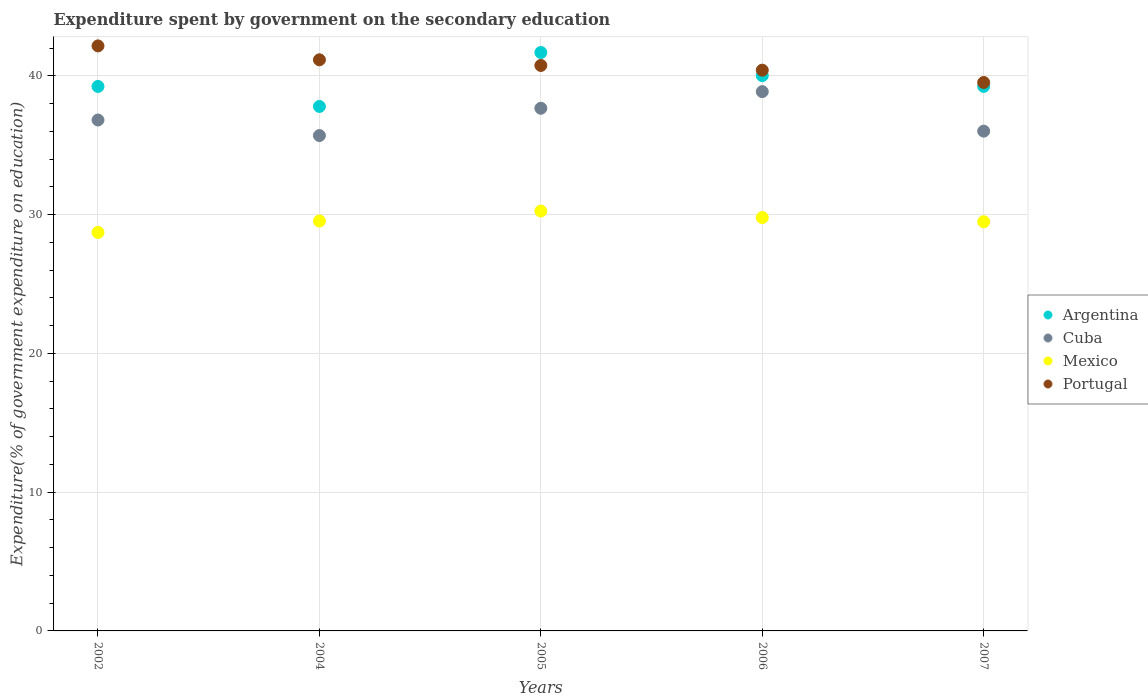What is the expenditure spent by government on the secondary education in Cuba in 2006?
Your answer should be compact. 38.87. Across all years, what is the maximum expenditure spent by government on the secondary education in Argentina?
Offer a terse response. 41.69. Across all years, what is the minimum expenditure spent by government on the secondary education in Mexico?
Ensure brevity in your answer.  28.72. In which year was the expenditure spent by government on the secondary education in Portugal minimum?
Offer a terse response. 2007. What is the total expenditure spent by government on the secondary education in Portugal in the graph?
Make the answer very short. 204.02. What is the difference between the expenditure spent by government on the secondary education in Cuba in 2002 and that in 2007?
Your answer should be compact. 0.8. What is the difference between the expenditure spent by government on the secondary education in Argentina in 2002 and the expenditure spent by government on the secondary education in Portugal in 2005?
Your response must be concise. -1.51. What is the average expenditure spent by government on the secondary education in Portugal per year?
Your answer should be very brief. 40.8. In the year 2005, what is the difference between the expenditure spent by government on the secondary education in Portugal and expenditure spent by government on the secondary education in Mexico?
Your answer should be compact. 10.49. What is the ratio of the expenditure spent by government on the secondary education in Mexico in 2004 to that in 2007?
Provide a succinct answer. 1. Is the expenditure spent by government on the secondary education in Mexico in 2002 less than that in 2004?
Your answer should be very brief. Yes. What is the difference between the highest and the second highest expenditure spent by government on the secondary education in Portugal?
Keep it short and to the point. 1. What is the difference between the highest and the lowest expenditure spent by government on the secondary education in Mexico?
Ensure brevity in your answer.  1.54. In how many years, is the expenditure spent by government on the secondary education in Mexico greater than the average expenditure spent by government on the secondary education in Mexico taken over all years?
Offer a terse response. 2. Is it the case that in every year, the sum of the expenditure spent by government on the secondary education in Mexico and expenditure spent by government on the secondary education in Portugal  is greater than the sum of expenditure spent by government on the secondary education in Cuba and expenditure spent by government on the secondary education in Argentina?
Keep it short and to the point. Yes. How many years are there in the graph?
Keep it short and to the point. 5. What is the difference between two consecutive major ticks on the Y-axis?
Keep it short and to the point. 10. Are the values on the major ticks of Y-axis written in scientific E-notation?
Keep it short and to the point. No. How many legend labels are there?
Provide a succinct answer. 4. What is the title of the graph?
Your response must be concise. Expenditure spent by government on the secondary education. Does "St. Martin (French part)" appear as one of the legend labels in the graph?
Keep it short and to the point. No. What is the label or title of the X-axis?
Your answer should be very brief. Years. What is the label or title of the Y-axis?
Offer a terse response. Expenditure(% of government expenditure on education). What is the Expenditure(% of government expenditure on education) in Argentina in 2002?
Ensure brevity in your answer.  39.24. What is the Expenditure(% of government expenditure on education) in Cuba in 2002?
Your answer should be very brief. 36.82. What is the Expenditure(% of government expenditure on education) of Mexico in 2002?
Provide a succinct answer. 28.72. What is the Expenditure(% of government expenditure on education) in Portugal in 2002?
Provide a succinct answer. 42.16. What is the Expenditure(% of government expenditure on education) in Argentina in 2004?
Offer a very short reply. 37.8. What is the Expenditure(% of government expenditure on education) in Cuba in 2004?
Your answer should be very brief. 35.7. What is the Expenditure(% of government expenditure on education) in Mexico in 2004?
Make the answer very short. 29.54. What is the Expenditure(% of government expenditure on education) in Portugal in 2004?
Ensure brevity in your answer.  41.16. What is the Expenditure(% of government expenditure on education) of Argentina in 2005?
Make the answer very short. 41.69. What is the Expenditure(% of government expenditure on education) in Cuba in 2005?
Your answer should be very brief. 37.67. What is the Expenditure(% of government expenditure on education) in Mexico in 2005?
Make the answer very short. 30.26. What is the Expenditure(% of government expenditure on education) of Portugal in 2005?
Make the answer very short. 40.75. What is the Expenditure(% of government expenditure on education) in Argentina in 2006?
Keep it short and to the point. 40.02. What is the Expenditure(% of government expenditure on education) of Cuba in 2006?
Offer a very short reply. 38.87. What is the Expenditure(% of government expenditure on education) of Mexico in 2006?
Your answer should be compact. 29.79. What is the Expenditure(% of government expenditure on education) of Portugal in 2006?
Your answer should be very brief. 40.41. What is the Expenditure(% of government expenditure on education) in Argentina in 2007?
Keep it short and to the point. 39.25. What is the Expenditure(% of government expenditure on education) in Cuba in 2007?
Provide a short and direct response. 36.02. What is the Expenditure(% of government expenditure on education) in Mexico in 2007?
Make the answer very short. 29.49. What is the Expenditure(% of government expenditure on education) in Portugal in 2007?
Your answer should be very brief. 39.53. Across all years, what is the maximum Expenditure(% of government expenditure on education) in Argentina?
Your answer should be very brief. 41.69. Across all years, what is the maximum Expenditure(% of government expenditure on education) of Cuba?
Make the answer very short. 38.87. Across all years, what is the maximum Expenditure(% of government expenditure on education) in Mexico?
Give a very brief answer. 30.26. Across all years, what is the maximum Expenditure(% of government expenditure on education) of Portugal?
Make the answer very short. 42.16. Across all years, what is the minimum Expenditure(% of government expenditure on education) of Argentina?
Your answer should be very brief. 37.8. Across all years, what is the minimum Expenditure(% of government expenditure on education) of Cuba?
Offer a very short reply. 35.7. Across all years, what is the minimum Expenditure(% of government expenditure on education) of Mexico?
Offer a very short reply. 28.72. Across all years, what is the minimum Expenditure(% of government expenditure on education) in Portugal?
Make the answer very short. 39.53. What is the total Expenditure(% of government expenditure on education) in Argentina in the graph?
Provide a succinct answer. 197.99. What is the total Expenditure(% of government expenditure on education) of Cuba in the graph?
Your answer should be very brief. 185.08. What is the total Expenditure(% of government expenditure on education) of Mexico in the graph?
Provide a succinct answer. 147.81. What is the total Expenditure(% of government expenditure on education) in Portugal in the graph?
Keep it short and to the point. 204.02. What is the difference between the Expenditure(% of government expenditure on education) of Argentina in 2002 and that in 2004?
Provide a succinct answer. 1.44. What is the difference between the Expenditure(% of government expenditure on education) in Cuba in 2002 and that in 2004?
Your answer should be very brief. 1.12. What is the difference between the Expenditure(% of government expenditure on education) in Mexico in 2002 and that in 2004?
Your response must be concise. -0.82. What is the difference between the Expenditure(% of government expenditure on education) in Argentina in 2002 and that in 2005?
Provide a succinct answer. -2.45. What is the difference between the Expenditure(% of government expenditure on education) of Cuba in 2002 and that in 2005?
Your response must be concise. -0.85. What is the difference between the Expenditure(% of government expenditure on education) of Mexico in 2002 and that in 2005?
Provide a short and direct response. -1.54. What is the difference between the Expenditure(% of government expenditure on education) of Portugal in 2002 and that in 2005?
Ensure brevity in your answer.  1.41. What is the difference between the Expenditure(% of government expenditure on education) of Argentina in 2002 and that in 2006?
Your answer should be compact. -0.78. What is the difference between the Expenditure(% of government expenditure on education) of Cuba in 2002 and that in 2006?
Provide a succinct answer. -2.05. What is the difference between the Expenditure(% of government expenditure on education) in Mexico in 2002 and that in 2006?
Your response must be concise. -1.07. What is the difference between the Expenditure(% of government expenditure on education) of Portugal in 2002 and that in 2006?
Provide a short and direct response. 1.75. What is the difference between the Expenditure(% of government expenditure on education) of Argentina in 2002 and that in 2007?
Your response must be concise. -0. What is the difference between the Expenditure(% of government expenditure on education) of Cuba in 2002 and that in 2007?
Make the answer very short. 0.8. What is the difference between the Expenditure(% of government expenditure on education) in Mexico in 2002 and that in 2007?
Offer a terse response. -0.77. What is the difference between the Expenditure(% of government expenditure on education) of Portugal in 2002 and that in 2007?
Make the answer very short. 2.64. What is the difference between the Expenditure(% of government expenditure on education) of Argentina in 2004 and that in 2005?
Make the answer very short. -3.89. What is the difference between the Expenditure(% of government expenditure on education) of Cuba in 2004 and that in 2005?
Give a very brief answer. -1.97. What is the difference between the Expenditure(% of government expenditure on education) of Mexico in 2004 and that in 2005?
Provide a succinct answer. -0.72. What is the difference between the Expenditure(% of government expenditure on education) of Portugal in 2004 and that in 2005?
Make the answer very short. 0.41. What is the difference between the Expenditure(% of government expenditure on education) in Argentina in 2004 and that in 2006?
Your answer should be compact. -2.22. What is the difference between the Expenditure(% of government expenditure on education) in Cuba in 2004 and that in 2006?
Offer a terse response. -3.17. What is the difference between the Expenditure(% of government expenditure on education) of Mexico in 2004 and that in 2006?
Your response must be concise. -0.25. What is the difference between the Expenditure(% of government expenditure on education) of Portugal in 2004 and that in 2006?
Your response must be concise. 0.75. What is the difference between the Expenditure(% of government expenditure on education) of Argentina in 2004 and that in 2007?
Give a very brief answer. -1.45. What is the difference between the Expenditure(% of government expenditure on education) of Cuba in 2004 and that in 2007?
Offer a very short reply. -0.32. What is the difference between the Expenditure(% of government expenditure on education) in Mexico in 2004 and that in 2007?
Your answer should be very brief. 0.05. What is the difference between the Expenditure(% of government expenditure on education) in Portugal in 2004 and that in 2007?
Keep it short and to the point. 1.63. What is the difference between the Expenditure(% of government expenditure on education) in Argentina in 2005 and that in 2006?
Keep it short and to the point. 1.67. What is the difference between the Expenditure(% of government expenditure on education) in Mexico in 2005 and that in 2006?
Provide a succinct answer. 0.47. What is the difference between the Expenditure(% of government expenditure on education) of Portugal in 2005 and that in 2006?
Your response must be concise. 0.34. What is the difference between the Expenditure(% of government expenditure on education) in Argentina in 2005 and that in 2007?
Give a very brief answer. 2.44. What is the difference between the Expenditure(% of government expenditure on education) in Cuba in 2005 and that in 2007?
Provide a short and direct response. 1.65. What is the difference between the Expenditure(% of government expenditure on education) of Mexico in 2005 and that in 2007?
Ensure brevity in your answer.  0.77. What is the difference between the Expenditure(% of government expenditure on education) of Portugal in 2005 and that in 2007?
Offer a terse response. 1.23. What is the difference between the Expenditure(% of government expenditure on education) in Argentina in 2006 and that in 2007?
Provide a succinct answer. 0.78. What is the difference between the Expenditure(% of government expenditure on education) in Cuba in 2006 and that in 2007?
Keep it short and to the point. 2.85. What is the difference between the Expenditure(% of government expenditure on education) of Mexico in 2006 and that in 2007?
Offer a very short reply. 0.3. What is the difference between the Expenditure(% of government expenditure on education) of Portugal in 2006 and that in 2007?
Make the answer very short. 0.89. What is the difference between the Expenditure(% of government expenditure on education) in Argentina in 2002 and the Expenditure(% of government expenditure on education) in Cuba in 2004?
Keep it short and to the point. 3.54. What is the difference between the Expenditure(% of government expenditure on education) of Argentina in 2002 and the Expenditure(% of government expenditure on education) of Mexico in 2004?
Your response must be concise. 9.7. What is the difference between the Expenditure(% of government expenditure on education) of Argentina in 2002 and the Expenditure(% of government expenditure on education) of Portugal in 2004?
Give a very brief answer. -1.92. What is the difference between the Expenditure(% of government expenditure on education) of Cuba in 2002 and the Expenditure(% of government expenditure on education) of Mexico in 2004?
Your response must be concise. 7.28. What is the difference between the Expenditure(% of government expenditure on education) in Cuba in 2002 and the Expenditure(% of government expenditure on education) in Portugal in 2004?
Your response must be concise. -4.34. What is the difference between the Expenditure(% of government expenditure on education) in Mexico in 2002 and the Expenditure(% of government expenditure on education) in Portugal in 2004?
Provide a short and direct response. -12.44. What is the difference between the Expenditure(% of government expenditure on education) in Argentina in 2002 and the Expenditure(% of government expenditure on education) in Cuba in 2005?
Give a very brief answer. 1.57. What is the difference between the Expenditure(% of government expenditure on education) in Argentina in 2002 and the Expenditure(% of government expenditure on education) in Mexico in 2005?
Keep it short and to the point. 8.98. What is the difference between the Expenditure(% of government expenditure on education) in Argentina in 2002 and the Expenditure(% of government expenditure on education) in Portugal in 2005?
Offer a very short reply. -1.51. What is the difference between the Expenditure(% of government expenditure on education) of Cuba in 2002 and the Expenditure(% of government expenditure on education) of Mexico in 2005?
Offer a terse response. 6.56. What is the difference between the Expenditure(% of government expenditure on education) in Cuba in 2002 and the Expenditure(% of government expenditure on education) in Portugal in 2005?
Provide a short and direct response. -3.93. What is the difference between the Expenditure(% of government expenditure on education) of Mexico in 2002 and the Expenditure(% of government expenditure on education) of Portugal in 2005?
Offer a very short reply. -12.03. What is the difference between the Expenditure(% of government expenditure on education) of Argentina in 2002 and the Expenditure(% of government expenditure on education) of Cuba in 2006?
Keep it short and to the point. 0.37. What is the difference between the Expenditure(% of government expenditure on education) of Argentina in 2002 and the Expenditure(% of government expenditure on education) of Mexico in 2006?
Your response must be concise. 9.45. What is the difference between the Expenditure(% of government expenditure on education) of Argentina in 2002 and the Expenditure(% of government expenditure on education) of Portugal in 2006?
Your response must be concise. -1.17. What is the difference between the Expenditure(% of government expenditure on education) in Cuba in 2002 and the Expenditure(% of government expenditure on education) in Mexico in 2006?
Provide a succinct answer. 7.03. What is the difference between the Expenditure(% of government expenditure on education) of Cuba in 2002 and the Expenditure(% of government expenditure on education) of Portugal in 2006?
Make the answer very short. -3.59. What is the difference between the Expenditure(% of government expenditure on education) of Mexico in 2002 and the Expenditure(% of government expenditure on education) of Portugal in 2006?
Your response must be concise. -11.69. What is the difference between the Expenditure(% of government expenditure on education) of Argentina in 2002 and the Expenditure(% of government expenditure on education) of Cuba in 2007?
Your response must be concise. 3.22. What is the difference between the Expenditure(% of government expenditure on education) in Argentina in 2002 and the Expenditure(% of government expenditure on education) in Mexico in 2007?
Offer a very short reply. 9.75. What is the difference between the Expenditure(% of government expenditure on education) in Argentina in 2002 and the Expenditure(% of government expenditure on education) in Portugal in 2007?
Keep it short and to the point. -0.29. What is the difference between the Expenditure(% of government expenditure on education) of Cuba in 2002 and the Expenditure(% of government expenditure on education) of Mexico in 2007?
Provide a succinct answer. 7.33. What is the difference between the Expenditure(% of government expenditure on education) of Cuba in 2002 and the Expenditure(% of government expenditure on education) of Portugal in 2007?
Ensure brevity in your answer.  -2.71. What is the difference between the Expenditure(% of government expenditure on education) of Mexico in 2002 and the Expenditure(% of government expenditure on education) of Portugal in 2007?
Offer a very short reply. -10.81. What is the difference between the Expenditure(% of government expenditure on education) in Argentina in 2004 and the Expenditure(% of government expenditure on education) in Cuba in 2005?
Ensure brevity in your answer.  0.13. What is the difference between the Expenditure(% of government expenditure on education) in Argentina in 2004 and the Expenditure(% of government expenditure on education) in Mexico in 2005?
Your answer should be compact. 7.54. What is the difference between the Expenditure(% of government expenditure on education) in Argentina in 2004 and the Expenditure(% of government expenditure on education) in Portugal in 2005?
Keep it short and to the point. -2.95. What is the difference between the Expenditure(% of government expenditure on education) in Cuba in 2004 and the Expenditure(% of government expenditure on education) in Mexico in 2005?
Provide a short and direct response. 5.44. What is the difference between the Expenditure(% of government expenditure on education) of Cuba in 2004 and the Expenditure(% of government expenditure on education) of Portugal in 2005?
Your answer should be very brief. -5.05. What is the difference between the Expenditure(% of government expenditure on education) of Mexico in 2004 and the Expenditure(% of government expenditure on education) of Portugal in 2005?
Offer a very short reply. -11.21. What is the difference between the Expenditure(% of government expenditure on education) in Argentina in 2004 and the Expenditure(% of government expenditure on education) in Cuba in 2006?
Your response must be concise. -1.07. What is the difference between the Expenditure(% of government expenditure on education) of Argentina in 2004 and the Expenditure(% of government expenditure on education) of Mexico in 2006?
Keep it short and to the point. 8.01. What is the difference between the Expenditure(% of government expenditure on education) in Argentina in 2004 and the Expenditure(% of government expenditure on education) in Portugal in 2006?
Provide a succinct answer. -2.62. What is the difference between the Expenditure(% of government expenditure on education) in Cuba in 2004 and the Expenditure(% of government expenditure on education) in Mexico in 2006?
Offer a terse response. 5.91. What is the difference between the Expenditure(% of government expenditure on education) of Cuba in 2004 and the Expenditure(% of government expenditure on education) of Portugal in 2006?
Give a very brief answer. -4.71. What is the difference between the Expenditure(% of government expenditure on education) of Mexico in 2004 and the Expenditure(% of government expenditure on education) of Portugal in 2006?
Provide a short and direct response. -10.87. What is the difference between the Expenditure(% of government expenditure on education) of Argentina in 2004 and the Expenditure(% of government expenditure on education) of Cuba in 2007?
Provide a succinct answer. 1.78. What is the difference between the Expenditure(% of government expenditure on education) in Argentina in 2004 and the Expenditure(% of government expenditure on education) in Mexico in 2007?
Make the answer very short. 8.31. What is the difference between the Expenditure(% of government expenditure on education) of Argentina in 2004 and the Expenditure(% of government expenditure on education) of Portugal in 2007?
Offer a terse response. -1.73. What is the difference between the Expenditure(% of government expenditure on education) in Cuba in 2004 and the Expenditure(% of government expenditure on education) in Mexico in 2007?
Your response must be concise. 6.21. What is the difference between the Expenditure(% of government expenditure on education) of Cuba in 2004 and the Expenditure(% of government expenditure on education) of Portugal in 2007?
Give a very brief answer. -3.83. What is the difference between the Expenditure(% of government expenditure on education) in Mexico in 2004 and the Expenditure(% of government expenditure on education) in Portugal in 2007?
Provide a succinct answer. -9.98. What is the difference between the Expenditure(% of government expenditure on education) of Argentina in 2005 and the Expenditure(% of government expenditure on education) of Cuba in 2006?
Ensure brevity in your answer.  2.82. What is the difference between the Expenditure(% of government expenditure on education) in Argentina in 2005 and the Expenditure(% of government expenditure on education) in Mexico in 2006?
Your response must be concise. 11.9. What is the difference between the Expenditure(% of government expenditure on education) of Argentina in 2005 and the Expenditure(% of government expenditure on education) of Portugal in 2006?
Give a very brief answer. 1.27. What is the difference between the Expenditure(% of government expenditure on education) of Cuba in 2005 and the Expenditure(% of government expenditure on education) of Mexico in 2006?
Make the answer very short. 7.88. What is the difference between the Expenditure(% of government expenditure on education) in Cuba in 2005 and the Expenditure(% of government expenditure on education) in Portugal in 2006?
Give a very brief answer. -2.75. What is the difference between the Expenditure(% of government expenditure on education) in Mexico in 2005 and the Expenditure(% of government expenditure on education) in Portugal in 2006?
Make the answer very short. -10.15. What is the difference between the Expenditure(% of government expenditure on education) in Argentina in 2005 and the Expenditure(% of government expenditure on education) in Cuba in 2007?
Your response must be concise. 5.67. What is the difference between the Expenditure(% of government expenditure on education) in Argentina in 2005 and the Expenditure(% of government expenditure on education) in Mexico in 2007?
Provide a short and direct response. 12.2. What is the difference between the Expenditure(% of government expenditure on education) of Argentina in 2005 and the Expenditure(% of government expenditure on education) of Portugal in 2007?
Make the answer very short. 2.16. What is the difference between the Expenditure(% of government expenditure on education) of Cuba in 2005 and the Expenditure(% of government expenditure on education) of Mexico in 2007?
Ensure brevity in your answer.  8.18. What is the difference between the Expenditure(% of government expenditure on education) in Cuba in 2005 and the Expenditure(% of government expenditure on education) in Portugal in 2007?
Offer a terse response. -1.86. What is the difference between the Expenditure(% of government expenditure on education) in Mexico in 2005 and the Expenditure(% of government expenditure on education) in Portugal in 2007?
Offer a terse response. -9.27. What is the difference between the Expenditure(% of government expenditure on education) of Argentina in 2006 and the Expenditure(% of government expenditure on education) of Cuba in 2007?
Provide a succinct answer. 4. What is the difference between the Expenditure(% of government expenditure on education) of Argentina in 2006 and the Expenditure(% of government expenditure on education) of Mexico in 2007?
Give a very brief answer. 10.53. What is the difference between the Expenditure(% of government expenditure on education) of Argentina in 2006 and the Expenditure(% of government expenditure on education) of Portugal in 2007?
Keep it short and to the point. 0.49. What is the difference between the Expenditure(% of government expenditure on education) in Cuba in 2006 and the Expenditure(% of government expenditure on education) in Mexico in 2007?
Provide a short and direct response. 9.38. What is the difference between the Expenditure(% of government expenditure on education) in Cuba in 2006 and the Expenditure(% of government expenditure on education) in Portugal in 2007?
Offer a terse response. -0.66. What is the difference between the Expenditure(% of government expenditure on education) of Mexico in 2006 and the Expenditure(% of government expenditure on education) of Portugal in 2007?
Your answer should be very brief. -9.74. What is the average Expenditure(% of government expenditure on education) in Argentina per year?
Provide a succinct answer. 39.6. What is the average Expenditure(% of government expenditure on education) of Cuba per year?
Provide a succinct answer. 37.02. What is the average Expenditure(% of government expenditure on education) in Mexico per year?
Your answer should be very brief. 29.56. What is the average Expenditure(% of government expenditure on education) in Portugal per year?
Your answer should be compact. 40.8. In the year 2002, what is the difference between the Expenditure(% of government expenditure on education) in Argentina and Expenditure(% of government expenditure on education) in Cuba?
Your response must be concise. 2.42. In the year 2002, what is the difference between the Expenditure(% of government expenditure on education) of Argentina and Expenditure(% of government expenditure on education) of Mexico?
Give a very brief answer. 10.52. In the year 2002, what is the difference between the Expenditure(% of government expenditure on education) of Argentina and Expenditure(% of government expenditure on education) of Portugal?
Keep it short and to the point. -2.92. In the year 2002, what is the difference between the Expenditure(% of government expenditure on education) in Cuba and Expenditure(% of government expenditure on education) in Mexico?
Ensure brevity in your answer.  8.1. In the year 2002, what is the difference between the Expenditure(% of government expenditure on education) of Cuba and Expenditure(% of government expenditure on education) of Portugal?
Keep it short and to the point. -5.34. In the year 2002, what is the difference between the Expenditure(% of government expenditure on education) in Mexico and Expenditure(% of government expenditure on education) in Portugal?
Keep it short and to the point. -13.44. In the year 2004, what is the difference between the Expenditure(% of government expenditure on education) in Argentina and Expenditure(% of government expenditure on education) in Cuba?
Ensure brevity in your answer.  2.1. In the year 2004, what is the difference between the Expenditure(% of government expenditure on education) in Argentina and Expenditure(% of government expenditure on education) in Mexico?
Provide a succinct answer. 8.25. In the year 2004, what is the difference between the Expenditure(% of government expenditure on education) of Argentina and Expenditure(% of government expenditure on education) of Portugal?
Keep it short and to the point. -3.36. In the year 2004, what is the difference between the Expenditure(% of government expenditure on education) in Cuba and Expenditure(% of government expenditure on education) in Mexico?
Offer a terse response. 6.16. In the year 2004, what is the difference between the Expenditure(% of government expenditure on education) in Cuba and Expenditure(% of government expenditure on education) in Portugal?
Ensure brevity in your answer.  -5.46. In the year 2004, what is the difference between the Expenditure(% of government expenditure on education) in Mexico and Expenditure(% of government expenditure on education) in Portugal?
Keep it short and to the point. -11.62. In the year 2005, what is the difference between the Expenditure(% of government expenditure on education) in Argentina and Expenditure(% of government expenditure on education) in Cuba?
Your answer should be compact. 4.02. In the year 2005, what is the difference between the Expenditure(% of government expenditure on education) in Argentina and Expenditure(% of government expenditure on education) in Mexico?
Your response must be concise. 11.43. In the year 2005, what is the difference between the Expenditure(% of government expenditure on education) in Argentina and Expenditure(% of government expenditure on education) in Portugal?
Provide a short and direct response. 0.93. In the year 2005, what is the difference between the Expenditure(% of government expenditure on education) in Cuba and Expenditure(% of government expenditure on education) in Mexico?
Give a very brief answer. 7.41. In the year 2005, what is the difference between the Expenditure(% of government expenditure on education) of Cuba and Expenditure(% of government expenditure on education) of Portugal?
Make the answer very short. -3.09. In the year 2005, what is the difference between the Expenditure(% of government expenditure on education) of Mexico and Expenditure(% of government expenditure on education) of Portugal?
Your answer should be very brief. -10.49. In the year 2006, what is the difference between the Expenditure(% of government expenditure on education) of Argentina and Expenditure(% of government expenditure on education) of Cuba?
Offer a very short reply. 1.15. In the year 2006, what is the difference between the Expenditure(% of government expenditure on education) of Argentina and Expenditure(% of government expenditure on education) of Mexico?
Offer a very short reply. 10.23. In the year 2006, what is the difference between the Expenditure(% of government expenditure on education) of Argentina and Expenditure(% of government expenditure on education) of Portugal?
Make the answer very short. -0.39. In the year 2006, what is the difference between the Expenditure(% of government expenditure on education) in Cuba and Expenditure(% of government expenditure on education) in Mexico?
Provide a short and direct response. 9.08. In the year 2006, what is the difference between the Expenditure(% of government expenditure on education) of Cuba and Expenditure(% of government expenditure on education) of Portugal?
Offer a very short reply. -1.55. In the year 2006, what is the difference between the Expenditure(% of government expenditure on education) in Mexico and Expenditure(% of government expenditure on education) in Portugal?
Offer a terse response. -10.62. In the year 2007, what is the difference between the Expenditure(% of government expenditure on education) in Argentina and Expenditure(% of government expenditure on education) in Cuba?
Keep it short and to the point. 3.23. In the year 2007, what is the difference between the Expenditure(% of government expenditure on education) of Argentina and Expenditure(% of government expenditure on education) of Mexico?
Offer a very short reply. 9.75. In the year 2007, what is the difference between the Expenditure(% of government expenditure on education) of Argentina and Expenditure(% of government expenditure on education) of Portugal?
Ensure brevity in your answer.  -0.28. In the year 2007, what is the difference between the Expenditure(% of government expenditure on education) of Cuba and Expenditure(% of government expenditure on education) of Mexico?
Provide a succinct answer. 6.53. In the year 2007, what is the difference between the Expenditure(% of government expenditure on education) in Cuba and Expenditure(% of government expenditure on education) in Portugal?
Your response must be concise. -3.51. In the year 2007, what is the difference between the Expenditure(% of government expenditure on education) of Mexico and Expenditure(% of government expenditure on education) of Portugal?
Provide a short and direct response. -10.04. What is the ratio of the Expenditure(% of government expenditure on education) in Argentina in 2002 to that in 2004?
Your answer should be very brief. 1.04. What is the ratio of the Expenditure(% of government expenditure on education) in Cuba in 2002 to that in 2004?
Provide a succinct answer. 1.03. What is the ratio of the Expenditure(% of government expenditure on education) in Mexico in 2002 to that in 2004?
Provide a succinct answer. 0.97. What is the ratio of the Expenditure(% of government expenditure on education) of Portugal in 2002 to that in 2004?
Offer a very short reply. 1.02. What is the ratio of the Expenditure(% of government expenditure on education) of Argentina in 2002 to that in 2005?
Provide a succinct answer. 0.94. What is the ratio of the Expenditure(% of government expenditure on education) of Cuba in 2002 to that in 2005?
Provide a succinct answer. 0.98. What is the ratio of the Expenditure(% of government expenditure on education) in Mexico in 2002 to that in 2005?
Provide a short and direct response. 0.95. What is the ratio of the Expenditure(% of government expenditure on education) in Portugal in 2002 to that in 2005?
Give a very brief answer. 1.03. What is the ratio of the Expenditure(% of government expenditure on education) of Argentina in 2002 to that in 2006?
Offer a terse response. 0.98. What is the ratio of the Expenditure(% of government expenditure on education) in Mexico in 2002 to that in 2006?
Offer a very short reply. 0.96. What is the ratio of the Expenditure(% of government expenditure on education) in Portugal in 2002 to that in 2006?
Give a very brief answer. 1.04. What is the ratio of the Expenditure(% of government expenditure on education) of Argentina in 2002 to that in 2007?
Offer a terse response. 1. What is the ratio of the Expenditure(% of government expenditure on education) of Cuba in 2002 to that in 2007?
Your response must be concise. 1.02. What is the ratio of the Expenditure(% of government expenditure on education) in Mexico in 2002 to that in 2007?
Your response must be concise. 0.97. What is the ratio of the Expenditure(% of government expenditure on education) in Portugal in 2002 to that in 2007?
Offer a very short reply. 1.07. What is the ratio of the Expenditure(% of government expenditure on education) of Argentina in 2004 to that in 2005?
Make the answer very short. 0.91. What is the ratio of the Expenditure(% of government expenditure on education) in Cuba in 2004 to that in 2005?
Your answer should be very brief. 0.95. What is the ratio of the Expenditure(% of government expenditure on education) in Mexico in 2004 to that in 2005?
Offer a terse response. 0.98. What is the ratio of the Expenditure(% of government expenditure on education) of Portugal in 2004 to that in 2005?
Provide a succinct answer. 1.01. What is the ratio of the Expenditure(% of government expenditure on education) of Argentina in 2004 to that in 2006?
Give a very brief answer. 0.94. What is the ratio of the Expenditure(% of government expenditure on education) in Cuba in 2004 to that in 2006?
Give a very brief answer. 0.92. What is the ratio of the Expenditure(% of government expenditure on education) of Portugal in 2004 to that in 2006?
Your answer should be compact. 1.02. What is the ratio of the Expenditure(% of government expenditure on education) of Argentina in 2004 to that in 2007?
Your response must be concise. 0.96. What is the ratio of the Expenditure(% of government expenditure on education) in Cuba in 2004 to that in 2007?
Ensure brevity in your answer.  0.99. What is the ratio of the Expenditure(% of government expenditure on education) of Portugal in 2004 to that in 2007?
Offer a very short reply. 1.04. What is the ratio of the Expenditure(% of government expenditure on education) in Argentina in 2005 to that in 2006?
Give a very brief answer. 1.04. What is the ratio of the Expenditure(% of government expenditure on education) of Cuba in 2005 to that in 2006?
Your answer should be very brief. 0.97. What is the ratio of the Expenditure(% of government expenditure on education) in Mexico in 2005 to that in 2006?
Provide a short and direct response. 1.02. What is the ratio of the Expenditure(% of government expenditure on education) of Portugal in 2005 to that in 2006?
Ensure brevity in your answer.  1.01. What is the ratio of the Expenditure(% of government expenditure on education) of Argentina in 2005 to that in 2007?
Your answer should be compact. 1.06. What is the ratio of the Expenditure(% of government expenditure on education) of Cuba in 2005 to that in 2007?
Make the answer very short. 1.05. What is the ratio of the Expenditure(% of government expenditure on education) of Mexico in 2005 to that in 2007?
Your response must be concise. 1.03. What is the ratio of the Expenditure(% of government expenditure on education) of Portugal in 2005 to that in 2007?
Your answer should be very brief. 1.03. What is the ratio of the Expenditure(% of government expenditure on education) in Argentina in 2006 to that in 2007?
Your response must be concise. 1.02. What is the ratio of the Expenditure(% of government expenditure on education) of Cuba in 2006 to that in 2007?
Ensure brevity in your answer.  1.08. What is the ratio of the Expenditure(% of government expenditure on education) of Mexico in 2006 to that in 2007?
Provide a succinct answer. 1.01. What is the ratio of the Expenditure(% of government expenditure on education) of Portugal in 2006 to that in 2007?
Make the answer very short. 1.02. What is the difference between the highest and the second highest Expenditure(% of government expenditure on education) in Argentina?
Offer a terse response. 1.67. What is the difference between the highest and the second highest Expenditure(% of government expenditure on education) in Mexico?
Provide a short and direct response. 0.47. What is the difference between the highest and the lowest Expenditure(% of government expenditure on education) in Argentina?
Provide a short and direct response. 3.89. What is the difference between the highest and the lowest Expenditure(% of government expenditure on education) in Cuba?
Your response must be concise. 3.17. What is the difference between the highest and the lowest Expenditure(% of government expenditure on education) in Mexico?
Give a very brief answer. 1.54. What is the difference between the highest and the lowest Expenditure(% of government expenditure on education) of Portugal?
Your response must be concise. 2.64. 